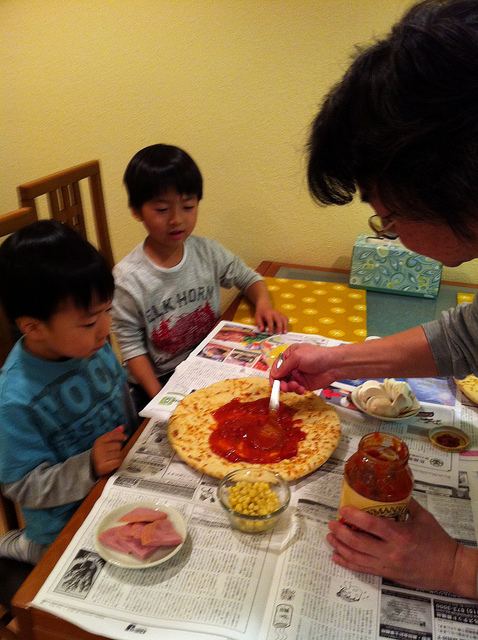Identify the text contained in this image. ELK HORN SESTT POCK 